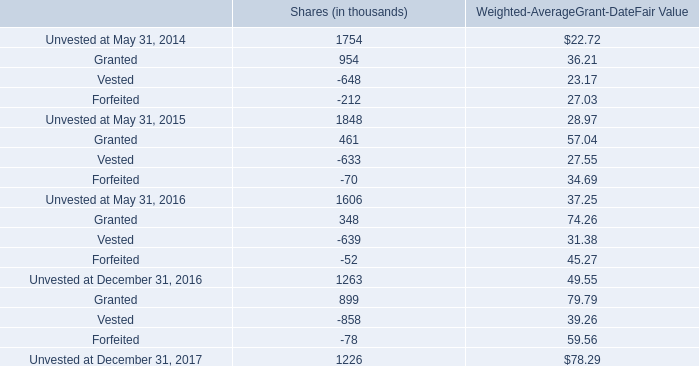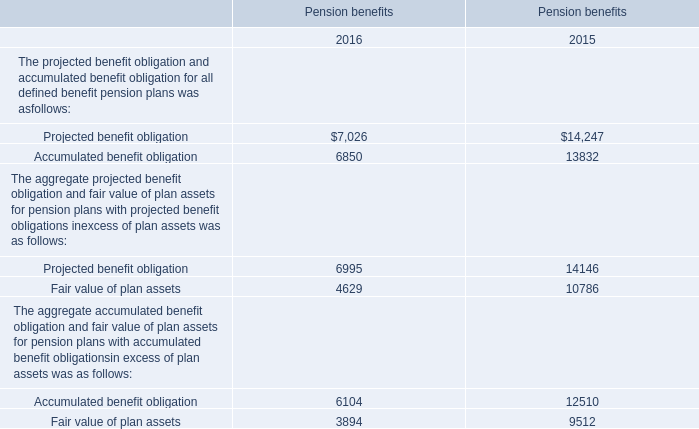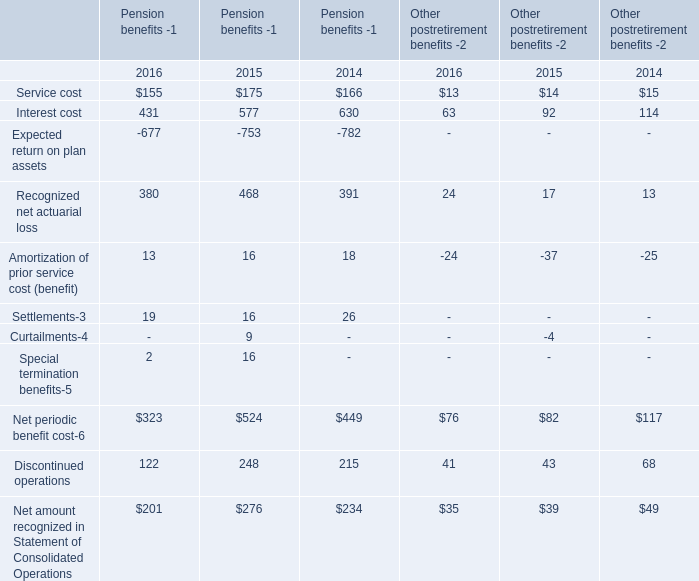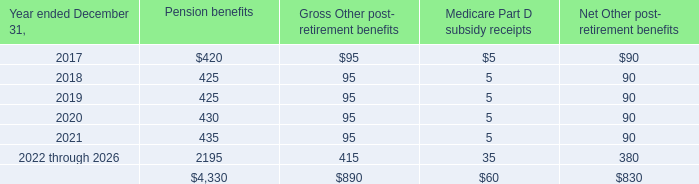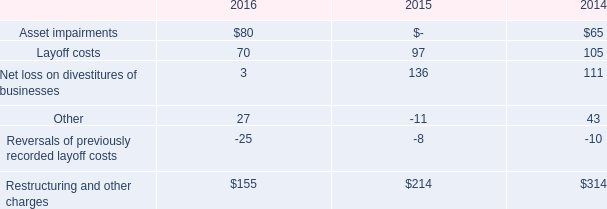What was the total amount of Pension benefits for The projected benefit obligation and accumulated benefit obligation for all defined benefit pension plans in 2015? 
Computations: (14247 + 13832)
Answer: 28079.0. 